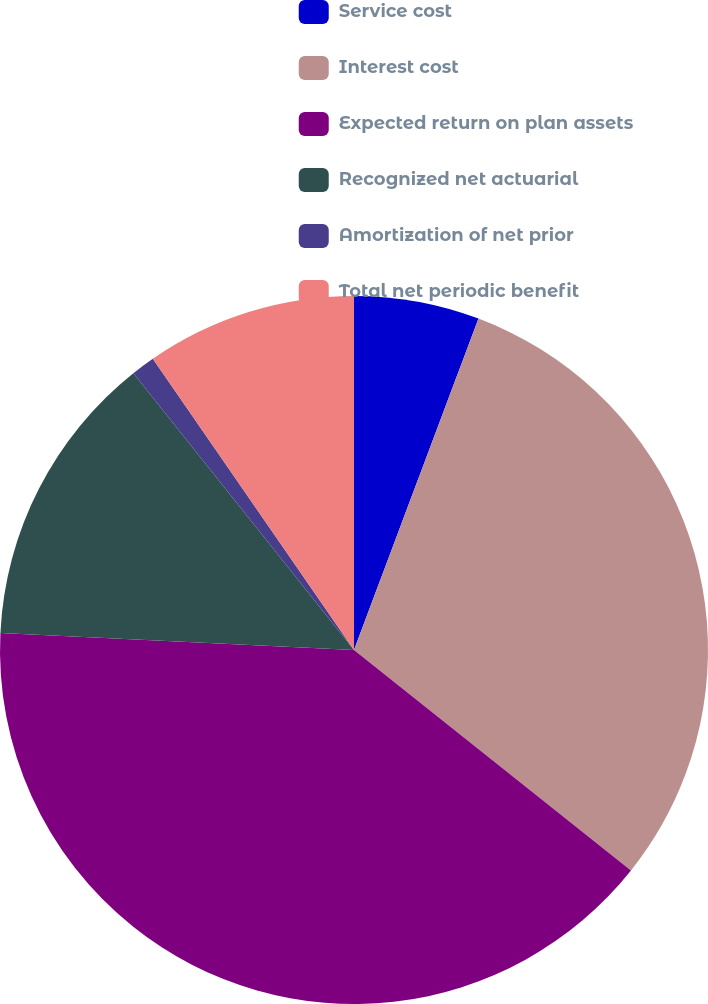Convert chart to OTSL. <chart><loc_0><loc_0><loc_500><loc_500><pie_chart><fcel>Service cost<fcel>Interest cost<fcel>Expected return on plan assets<fcel>Recognized net actuarial<fcel>Amortization of net prior<fcel>Total net periodic benefit<nl><fcel>5.72%<fcel>29.98%<fcel>40.07%<fcel>13.52%<fcel>1.09%<fcel>9.62%<nl></chart> 